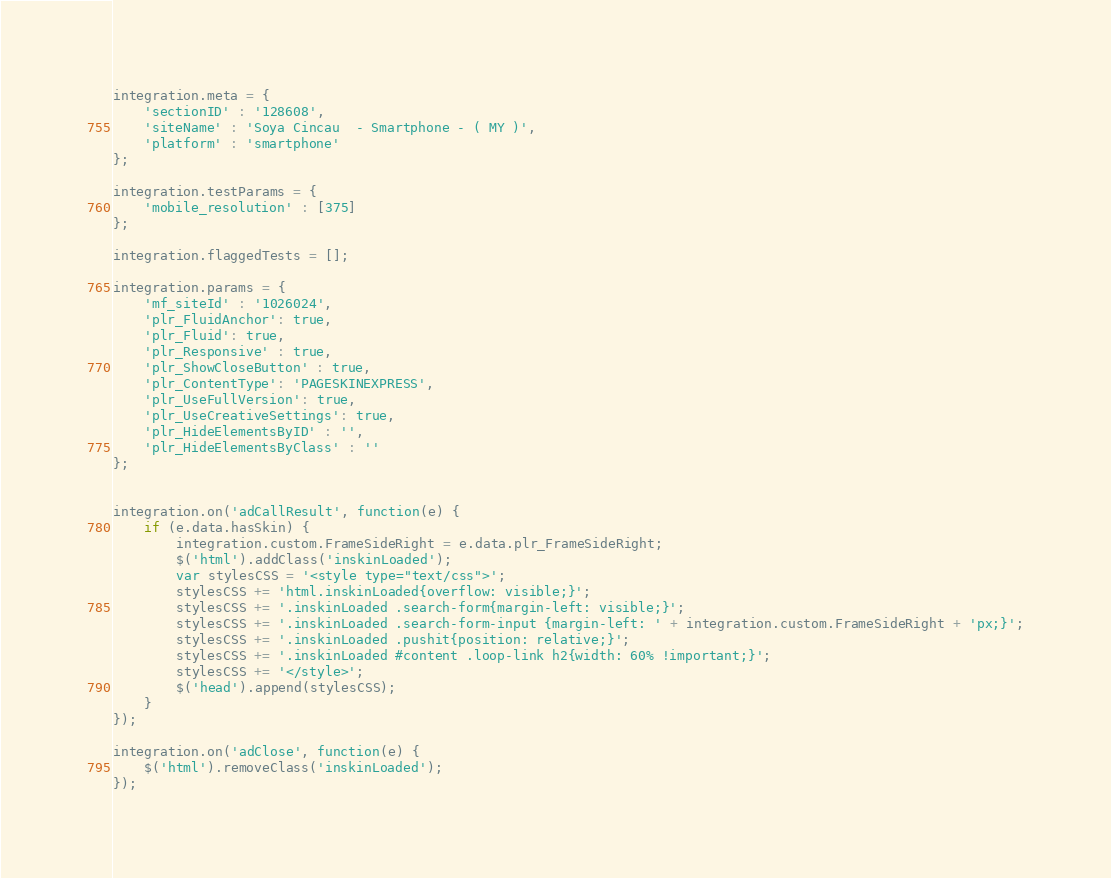<code> <loc_0><loc_0><loc_500><loc_500><_JavaScript_>integration.meta = {
    'sectionID' : '128608',
    'siteName' : 'Soya Cincau  - Smartphone - ( MY )',
    'platform' : 'smartphone'
};

integration.testParams = {
    'mobile_resolution' : [375]
};

integration.flaggedTests = [];

integration.params = {
    'mf_siteId' : '1026024',
    'plr_FluidAnchor': true,
    'plr_Fluid': true,
    'plr_Responsive' : true,
    'plr_ShowCloseButton' : true,
    'plr_ContentType': 'PAGESKINEXPRESS',
    'plr_UseFullVersion': true,
    'plr_UseCreativeSettings': true,
    'plr_HideElementsByID' : '',
    'plr_HideElementsByClass' : ''
};


integration.on('adCallResult', function(e) {
    if (e.data.hasSkin) {
        integration.custom.FrameSideRight = e.data.plr_FrameSideRight;
        $('html').addClass('inskinLoaded');
        var stylesCSS = '<style type="text/css">';
        stylesCSS += 'html.inskinLoaded{overflow: visible;}';
        stylesCSS += '.inskinLoaded .search-form{margin-left: visible;}';
        stylesCSS += '.inskinLoaded .search-form-input {margin-left: ' + integration.custom.FrameSideRight + 'px;}';
        stylesCSS += '.inskinLoaded .pushit{position: relative;}';
        stylesCSS += '.inskinLoaded #content .loop-link h2{width: 60% !important;}';
        stylesCSS += '</style>';
        $('head').append(stylesCSS);
    }
});

integration.on('adClose', function(e) {
    $('html').removeClass('inskinLoaded');
});
</code> 